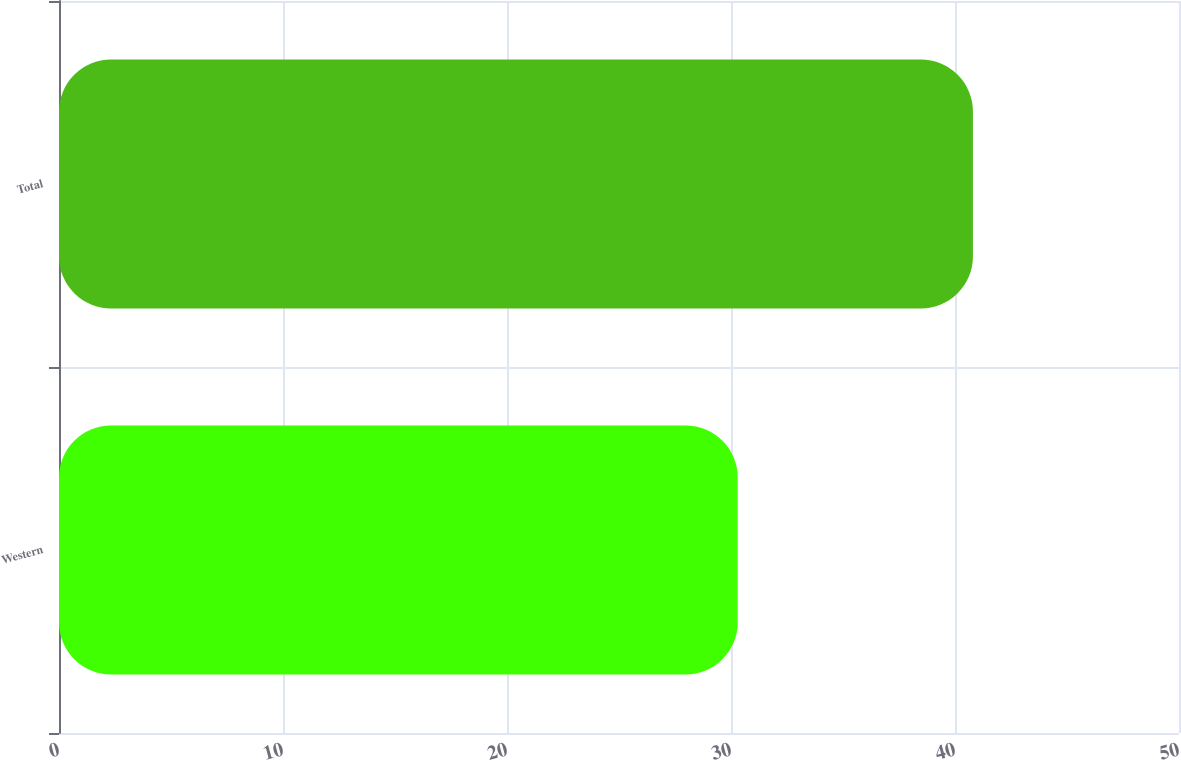Convert chart to OTSL. <chart><loc_0><loc_0><loc_500><loc_500><bar_chart><fcel>Western<fcel>Total<nl><fcel>30.3<fcel>40.8<nl></chart> 